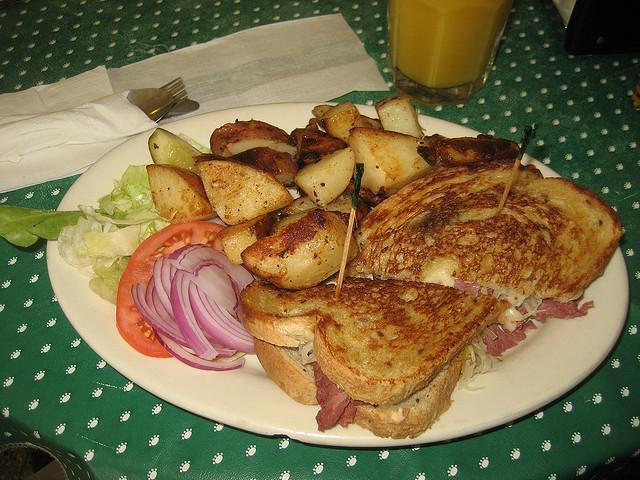How many different food groups are on the plate?
Give a very brief answer. 3. How many fries on the plate?
Give a very brief answer. 0. How many sandwiches are there?
Give a very brief answer. 2. 